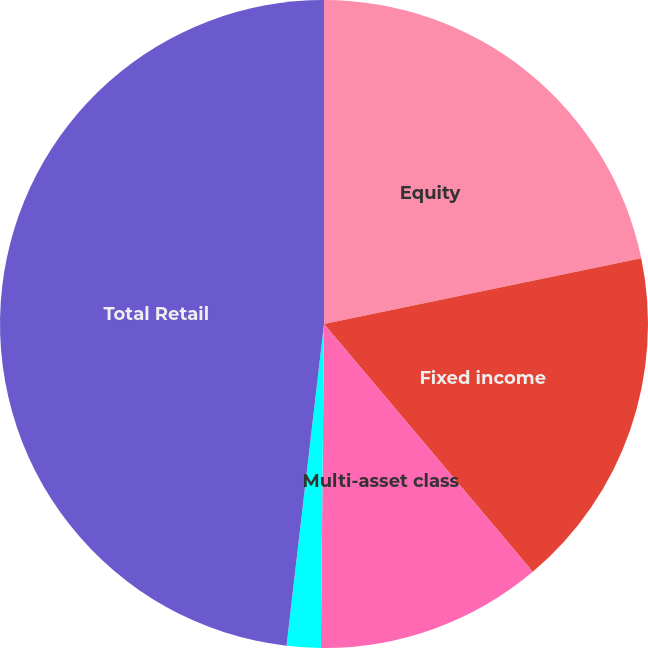<chart> <loc_0><loc_0><loc_500><loc_500><pie_chart><fcel>Equity<fcel>Fixed income<fcel>Multi-asset class<fcel>Alternatives<fcel>Total Retail<nl><fcel>21.75%<fcel>17.11%<fcel>11.3%<fcel>1.69%<fcel>48.16%<nl></chart> 